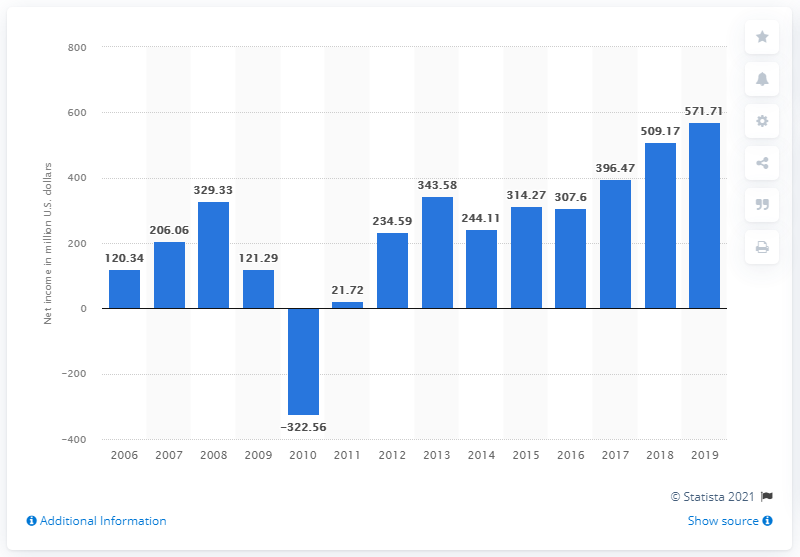Give some essential details in this illustration. Bandai Namco's net income in 2019 was JPY 571.71 million. 